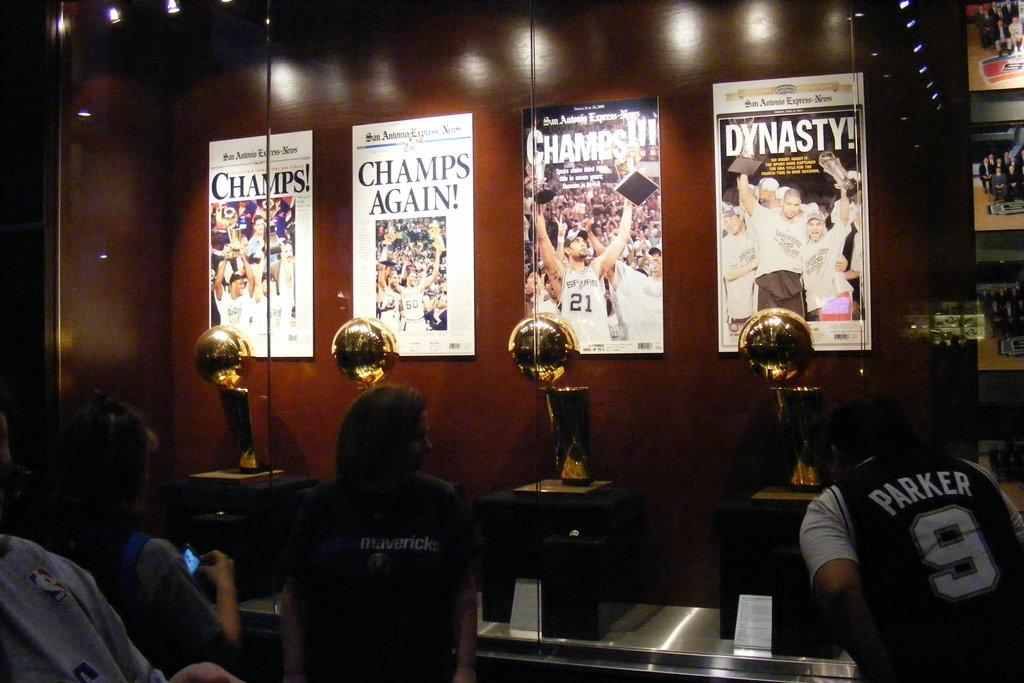<image>
Create a compact narrative representing the image presented. Several posters on a red wall, one of which bears the word Dynasty with an exclamation mark. 